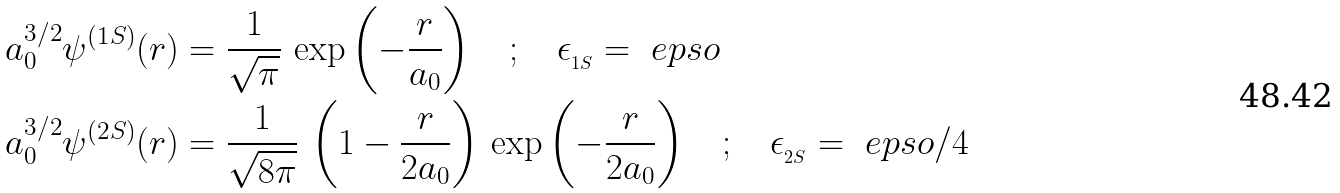<formula> <loc_0><loc_0><loc_500><loc_500>a _ { 0 } ^ { 3 / 2 } \psi ^ { ( 1 S ) } ( r ) & = \frac { 1 } { \sqrt { \pi } } \, \exp \left ( - \frac { r } { a _ { 0 } } \right ) \quad ; \quad \epsilon _ { _ { 1 S } } = \ e p s o \\ a _ { 0 } ^ { 3 / 2 } \psi ^ { ( 2 S ) } ( r ) & = \frac { 1 } { \sqrt { 8 \pi } } \, \left ( 1 - \frac { r } { 2 a _ { 0 } } \right ) \, \exp \left ( - \frac { r } { 2 a _ { 0 } } \right ) \quad ; \quad \epsilon _ { _ { 2 S } } = \ e p s o / 4</formula> 